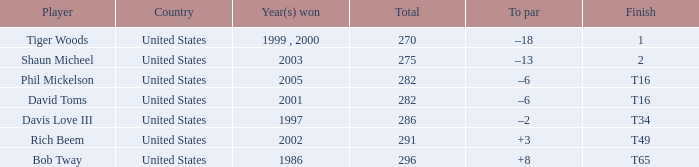What is the to par value of the one who succeeded in 2003? –13. 